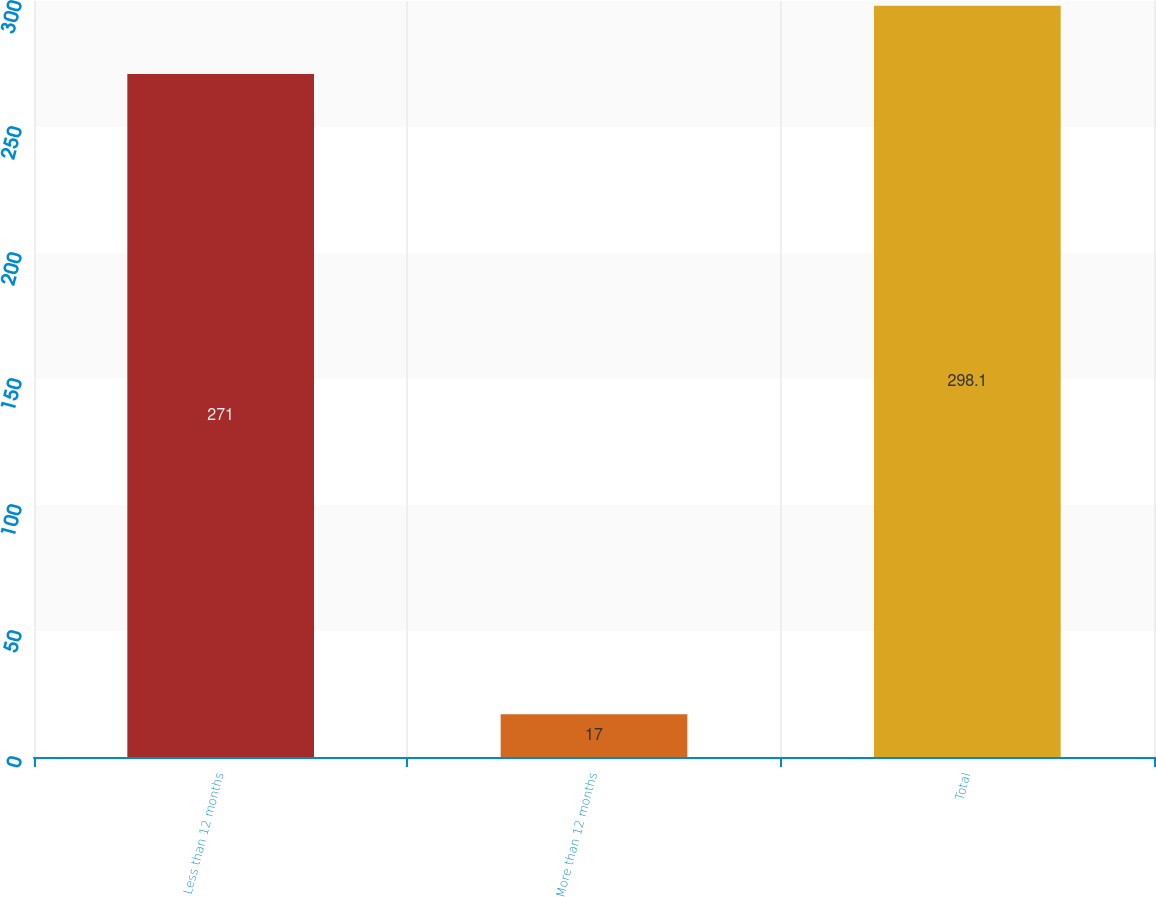Convert chart to OTSL. <chart><loc_0><loc_0><loc_500><loc_500><bar_chart><fcel>Less than 12 months<fcel>More than 12 months<fcel>Total<nl><fcel>271<fcel>17<fcel>298.1<nl></chart> 